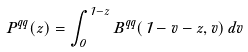Convert formula to latex. <formula><loc_0><loc_0><loc_500><loc_500>P ^ { q q } ( z ) = \int _ { 0 } ^ { 1 - z } B ^ { q q } ( 1 - v - z , v ) \, d v</formula> 